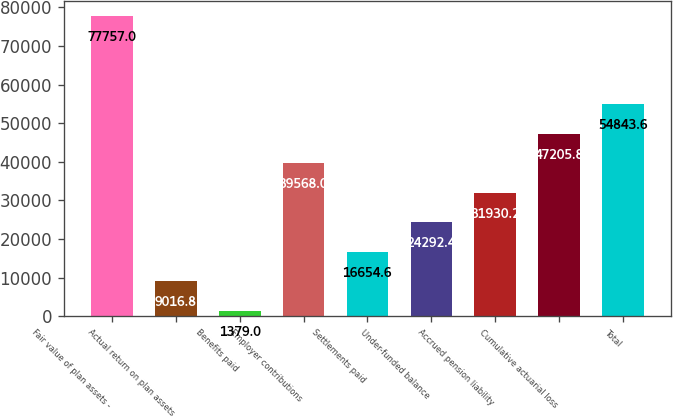Convert chart. <chart><loc_0><loc_0><loc_500><loc_500><bar_chart><fcel>Fair value of plan assets -<fcel>Actual return on plan assets<fcel>Benefits paid<fcel>Employer contributions<fcel>Settlements paid<fcel>Under-funded balance<fcel>Accrued pension liability<fcel>Cumulative actuarial loss<fcel>Total<nl><fcel>77757<fcel>9016.8<fcel>1379<fcel>39568<fcel>16654.6<fcel>24292.4<fcel>31930.2<fcel>47205.8<fcel>54843.6<nl></chart> 